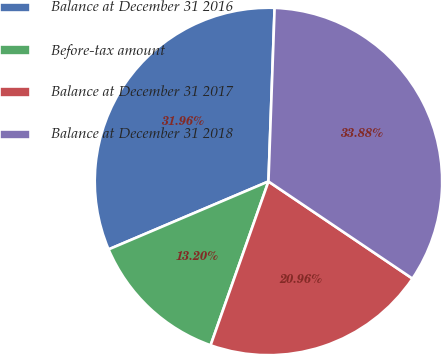Convert chart to OTSL. <chart><loc_0><loc_0><loc_500><loc_500><pie_chart><fcel>Balance at December 31 2016<fcel>Before-tax amount<fcel>Balance at December 31 2017<fcel>Balance at December 31 2018<nl><fcel>31.96%<fcel>13.2%<fcel>20.96%<fcel>33.88%<nl></chart> 